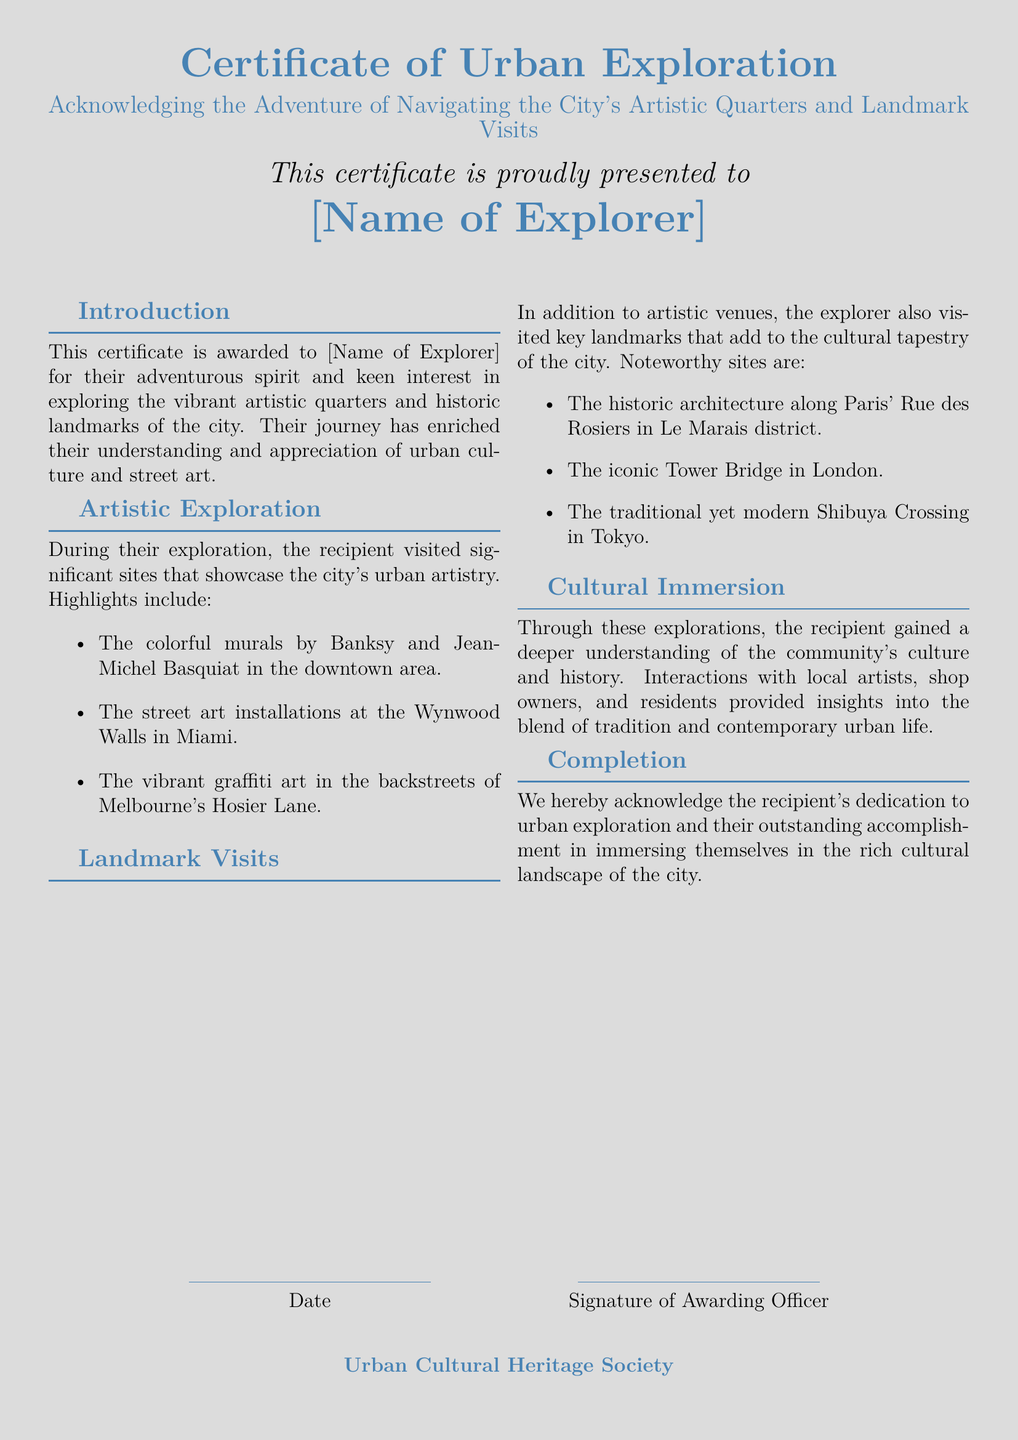What is the title of the certificate? The title of the certificate is clearly stated in the document as the "Certificate of Urban Exploration."
Answer: Certificate of Urban Exploration Who is the certificate presented to? The document specifies that the certificate is presented to "[Name of Explorer]."
Answer: [Name of Explorer] What section outlines the artistic exploration undertaken? The section that outlines the artistic exploration is labeled "Artistic Exploration."
Answer: Artistic Exploration Which city is mentioned for the historic architecture along Rue des Rosiers? The city where this historic architecture is found is Paris, as stated in the document.
Answer: Paris What is one of the notable street art locations mentioned? One notable street art location mentioned is the Wynwood Walls in Miami.
Answer: Wynwood Walls How many significant sites of urban artistry were highlighted in the document? There are three significant sites of urban artistry highlighted, which can be counted in the "Artistic Exploration" section.
Answer: Three What describes the completion of the certificate issuance? The issuance of the certificate is described in the "Completion" section as an acknowledgment of dedication to urban exploration.
Answer: Completion What organization awards the certificate? The organization that awards the certificate is named "Urban Cultural Heritage Society."
Answer: Urban Cultural Heritage Society Which landmark is noted for its iconic structure in London? The iconic landmark noted in London is the Tower Bridge.
Answer: Tower Bridge 